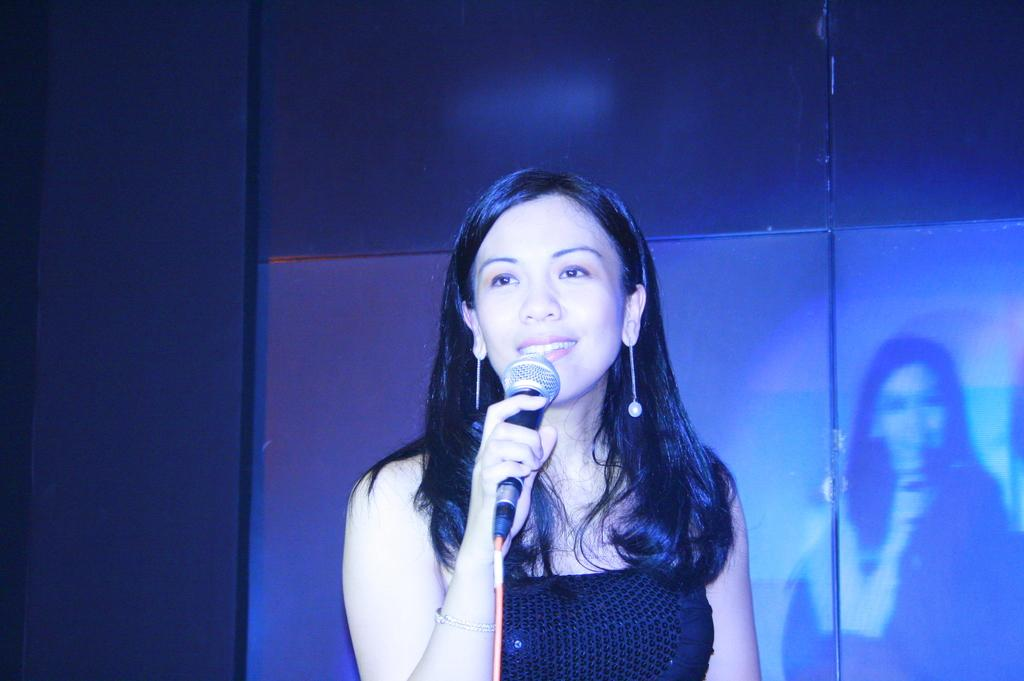Who is the main subject in the image? There is a lady in the center of the image. What is the lady doing in the image? The lady is standing and holding a mic. What can be seen in the background of the image? There is a wall in the background of the image. Is the lady's daughter present in the image? There is no mention of a daughter in the provided facts, so we cannot determine if the lady's daughter is present in the image. --- Facts: 1. There is a car in the image. 2. The car is red. 3. The car has four wheels. 4. There is a road in the image. 5. The road is paved. Absurd Topics: parrot, sand, mountain Conversation: What is the main subject in the image? There is a car in the image. What color is the car? The car is red. How many wheels does the car have? The car has four wheels. What can be seen in the background of the image? There is a road in the image. What type of road is visible in the image? The road is paved. Reasoning: Let's think step by step in order to produce the conversation. We start by identifying the main subject in the image, which is the car. Then, we describe the car's color and the number of wheels it has. Next, we mention the background of the image, which includes a road. Finally, we provide a detail about the road, which is that it is paved. Each question is designed to elicit a specific detail about the image that is known from the provided facts. Absurd Question/Answer: Can you see a parrot sitting on the car in the image? There is no mention of a parrot in the provided facts, so we cannot determine if a parrot is present in the image. 